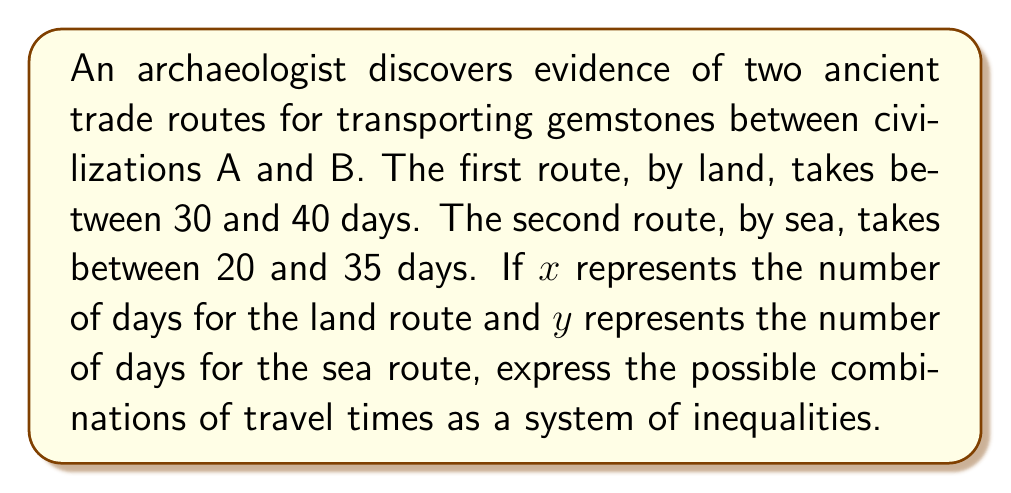Can you solve this math problem? Let's approach this step-by-step:

1) For the land route:
   - The minimum time is 30 days
   - The maximum time is 40 days
   We can express this as: $30 \leq x \leq 40$

2) For the sea route:
   - The minimum time is 20 days
   - The maximum time is 35 days
   We can express this as: $20 \leq y \leq 35$

3) Combining these inequalities, we get a system of inequalities:

   $$\begin{cases}
   30 \leq x \leq 40 \\
   20 \leq y \leq 35
   \end{cases}$$

4) This system of inequalities represents all possible combinations of travel times for the two routes.

5) Geometrically, this system of inequalities would represent a rectangle in the xy-plane, with corners at the points (30, 20), (30, 35), (40, 20), and (40, 35).

[asy]
unitsize(4mm);
draw((0,0)--(50,0), arrow=Arrow);
draw((0,0)--(0,50), arrow=Arrow);
draw((30,20)--(40,20)--(40,35)--(30,35)--cycle);
label("x", (50,0), E);
label("y", (0,50), N);
label("(30,20)", (30,20), SW);
label("(40,35)", (40,35), NE);
[/asy]
Answer: $$\begin{cases}
30 \leq x \leq 40 \\
20 \leq y \leq 35
\end{cases}$$ 